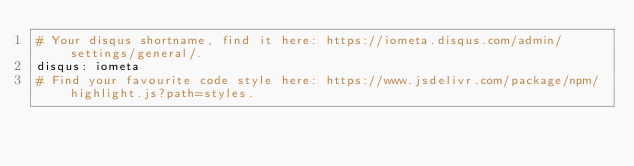<code> <loc_0><loc_0><loc_500><loc_500><_YAML_># Your disqus shortname, find it here: https://iometa.disqus.com/admin/settings/general/.
disqus: iometa
# Find your favourite code style here: https://www.jsdelivr.com/package/npm/highlight.js?path=styles.</code> 